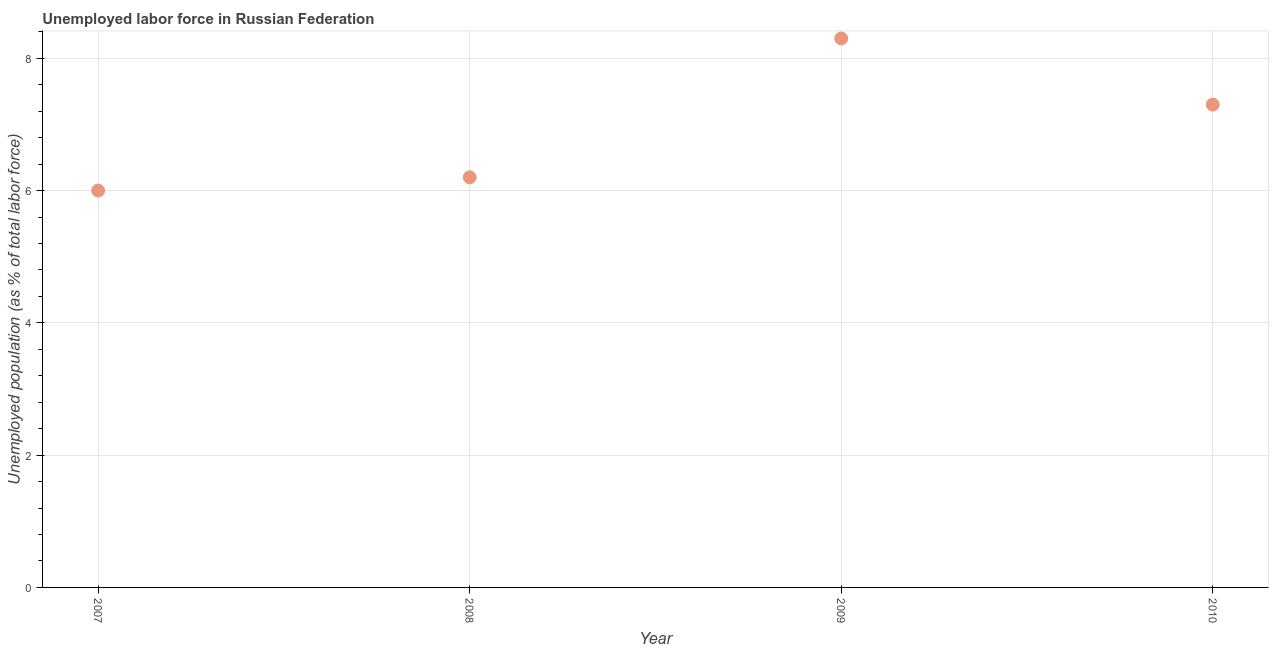What is the total unemployed population in 2008?
Your answer should be very brief. 6.2. Across all years, what is the maximum total unemployed population?
Ensure brevity in your answer.  8.3. Across all years, what is the minimum total unemployed population?
Provide a succinct answer. 6. In which year was the total unemployed population maximum?
Your response must be concise. 2009. In which year was the total unemployed population minimum?
Your answer should be very brief. 2007. What is the sum of the total unemployed population?
Your response must be concise. 27.8. What is the difference between the total unemployed population in 2008 and 2009?
Your response must be concise. -2.1. What is the average total unemployed population per year?
Make the answer very short. 6.95. What is the median total unemployed population?
Offer a very short reply. 6.75. In how many years, is the total unemployed population greater than 6.4 %?
Provide a short and direct response. 2. What is the ratio of the total unemployed population in 2008 to that in 2010?
Provide a short and direct response. 0.85. Is the total unemployed population in 2007 less than that in 2010?
Your answer should be very brief. Yes. What is the difference between the highest and the second highest total unemployed population?
Keep it short and to the point. 1. What is the difference between the highest and the lowest total unemployed population?
Give a very brief answer. 2.3. Does the total unemployed population monotonically increase over the years?
Provide a short and direct response. No. How many years are there in the graph?
Provide a succinct answer. 4. What is the difference between two consecutive major ticks on the Y-axis?
Offer a terse response. 2. Are the values on the major ticks of Y-axis written in scientific E-notation?
Your answer should be very brief. No. Does the graph contain grids?
Your answer should be compact. Yes. What is the title of the graph?
Make the answer very short. Unemployed labor force in Russian Federation. What is the label or title of the X-axis?
Your answer should be very brief. Year. What is the label or title of the Y-axis?
Provide a short and direct response. Unemployed population (as % of total labor force). What is the Unemployed population (as % of total labor force) in 2007?
Make the answer very short. 6. What is the Unemployed population (as % of total labor force) in 2008?
Provide a succinct answer. 6.2. What is the Unemployed population (as % of total labor force) in 2009?
Ensure brevity in your answer.  8.3. What is the Unemployed population (as % of total labor force) in 2010?
Provide a short and direct response. 7.3. What is the difference between the Unemployed population (as % of total labor force) in 2007 and 2008?
Offer a terse response. -0.2. What is the difference between the Unemployed population (as % of total labor force) in 2007 and 2009?
Provide a short and direct response. -2.3. What is the difference between the Unemployed population (as % of total labor force) in 2007 and 2010?
Make the answer very short. -1.3. What is the difference between the Unemployed population (as % of total labor force) in 2008 and 2009?
Your response must be concise. -2.1. What is the difference between the Unemployed population (as % of total labor force) in 2008 and 2010?
Keep it short and to the point. -1.1. What is the ratio of the Unemployed population (as % of total labor force) in 2007 to that in 2008?
Your answer should be compact. 0.97. What is the ratio of the Unemployed population (as % of total labor force) in 2007 to that in 2009?
Offer a terse response. 0.72. What is the ratio of the Unemployed population (as % of total labor force) in 2007 to that in 2010?
Give a very brief answer. 0.82. What is the ratio of the Unemployed population (as % of total labor force) in 2008 to that in 2009?
Give a very brief answer. 0.75. What is the ratio of the Unemployed population (as % of total labor force) in 2008 to that in 2010?
Your answer should be very brief. 0.85. What is the ratio of the Unemployed population (as % of total labor force) in 2009 to that in 2010?
Make the answer very short. 1.14. 